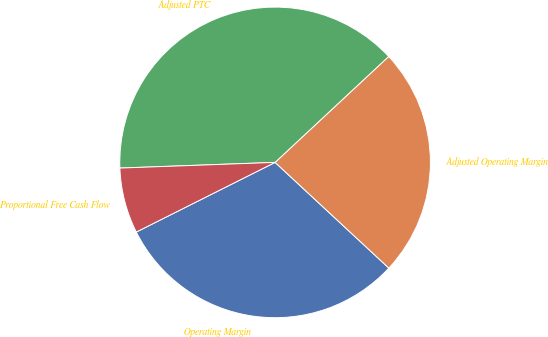<chart> <loc_0><loc_0><loc_500><loc_500><pie_chart><fcel>Operating Margin<fcel>Adjusted Operating Margin<fcel>Adjusted PTC<fcel>Proportional Free Cash Flow<nl><fcel>30.68%<fcel>23.86%<fcel>38.64%<fcel>6.82%<nl></chart> 